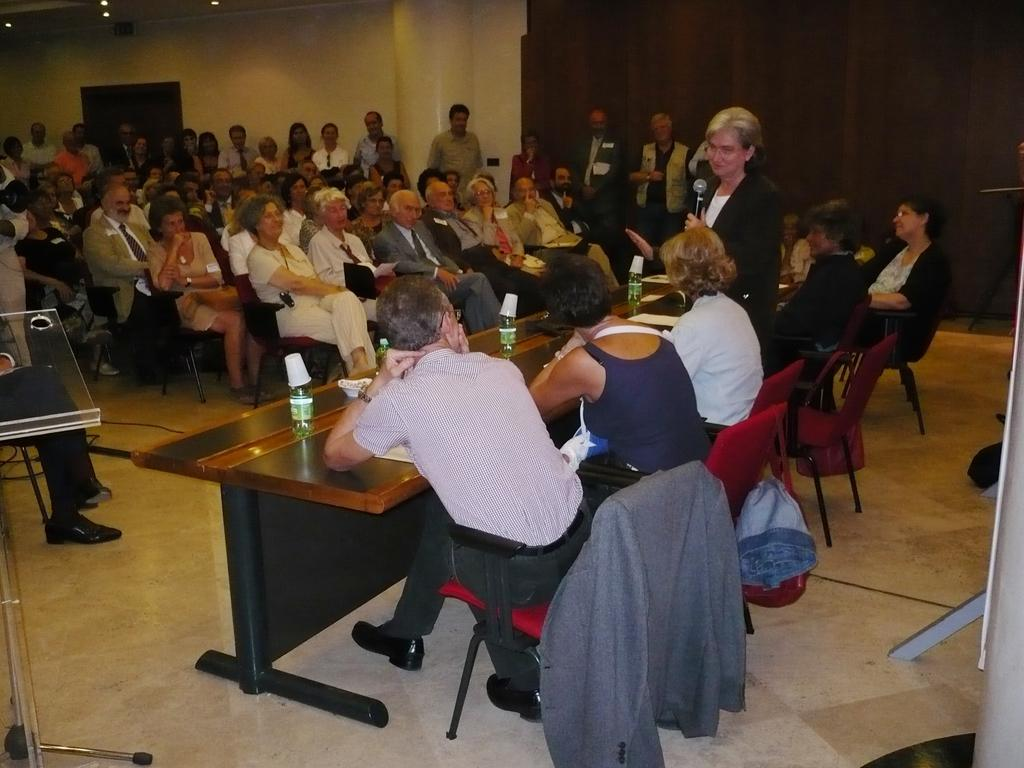What are the people in the image doing? There are people sitting on chairs and standing in the image. What is present in the image besides the people? There is a table in the image. What can be found on the table? There are bottles on the table. What can be seen in the background of the image? There is a wall in the background of the image. How many legs of mint are visible in the image? There is no mint present in the image, so it is not possible to determine the number of legs of mint. 